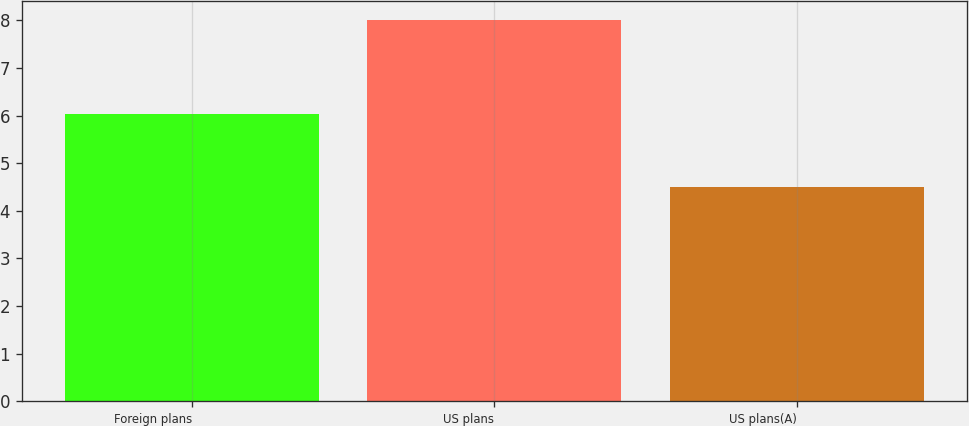Convert chart. <chart><loc_0><loc_0><loc_500><loc_500><bar_chart><fcel>Foreign plans<fcel>US plans<fcel>US plans(A)<nl><fcel>6.03<fcel>8<fcel>4.5<nl></chart> 